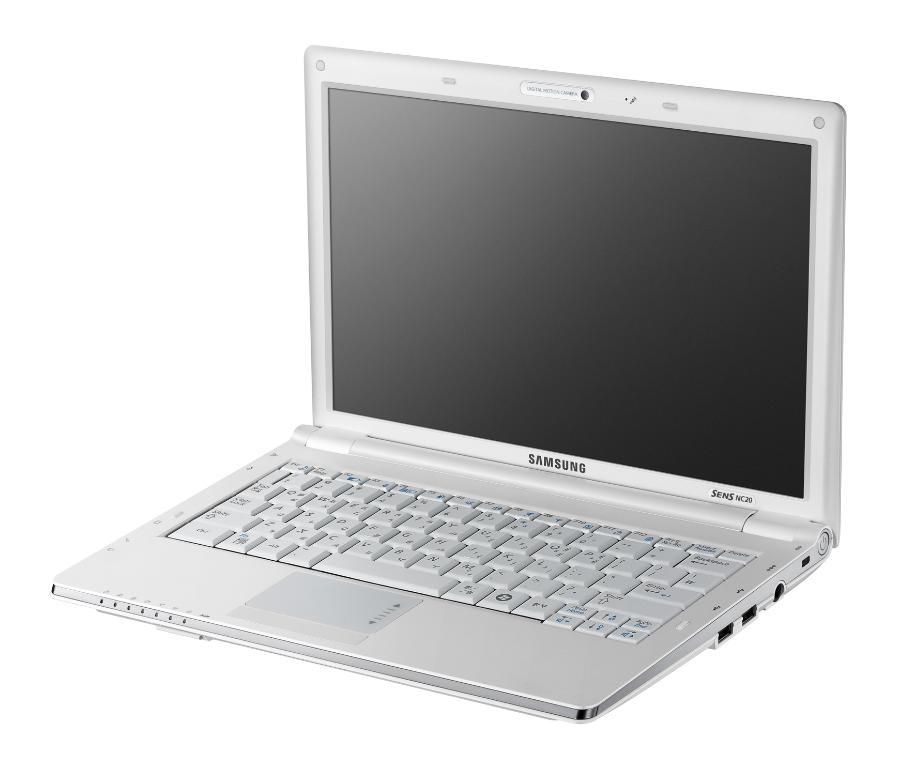What brand is this computer?
Provide a short and direct response. Samsung. 